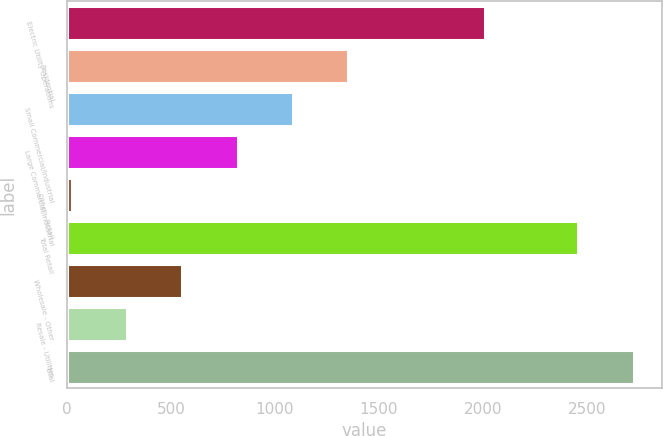<chart> <loc_0><loc_0><loc_500><loc_500><bar_chart><fcel>Electric Utility Operations<fcel>Residential<fcel>Small Commercial/Industrial<fcel>Large Commercial/Industrial<fcel>Other - Retail<fcel>Total Retail<fcel>Wholesale - Other<fcel>Resale - Utilities<fcel>Total<nl><fcel>2009<fcel>1353.1<fcel>1086.72<fcel>820.34<fcel>21.2<fcel>2458.5<fcel>553.96<fcel>287.58<fcel>2724.88<nl></chart> 